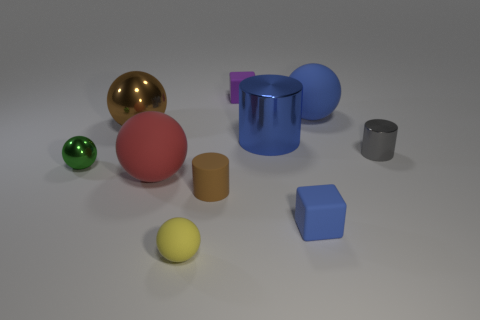Do the large matte ball on the right side of the tiny rubber sphere and the big shiny cylinder have the same color?
Make the answer very short. Yes. There is a cube behind the blue rubber thing in front of the blue thing that is behind the blue metallic cylinder; how big is it?
Provide a succinct answer. Small. There is a matte object that is behind the large blue metallic cylinder and in front of the tiny purple rubber cube; what size is it?
Offer a very short reply. Large. Do the large matte ball to the right of the small yellow ball and the tiny cylinder behind the brown matte object have the same color?
Your answer should be very brief. No. There is a brown metal object; what number of cubes are in front of it?
Make the answer very short. 1. There is a blue rubber thing in front of the ball right of the purple matte object; is there a small yellow matte thing behind it?
Your answer should be compact. No. How many red objects are the same size as the blue matte sphere?
Your answer should be very brief. 1. There is a small block in front of the rubber ball to the right of the tiny purple object; what is it made of?
Provide a short and direct response. Rubber. What shape is the big thing that is in front of the tiny metal thing on the left side of the block that is in front of the large blue rubber thing?
Provide a succinct answer. Sphere. There is a large red rubber object that is on the left side of the big blue cylinder; is it the same shape as the tiny metal object in front of the gray thing?
Ensure brevity in your answer.  Yes. 